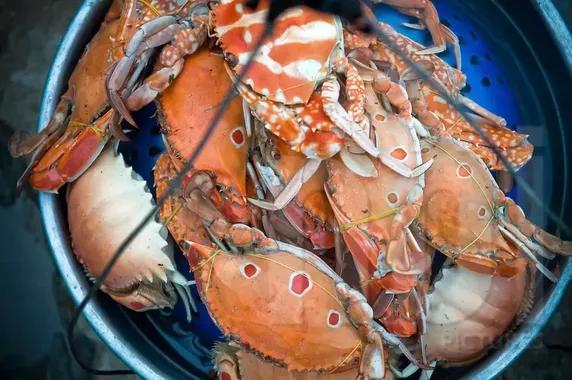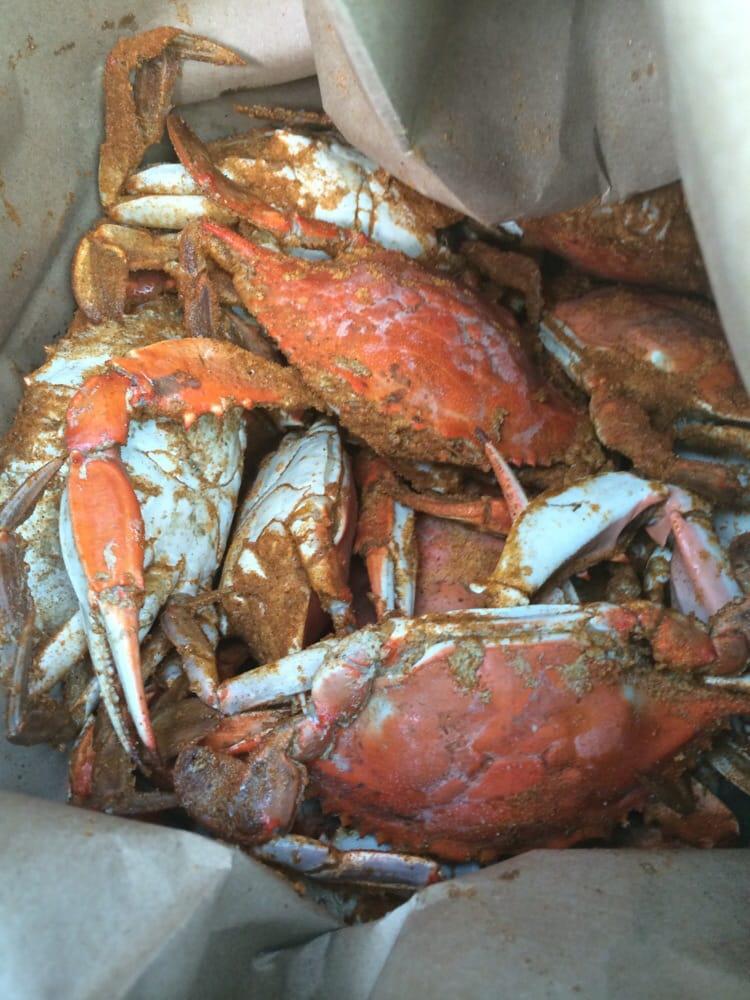The first image is the image on the left, the second image is the image on the right. Given the left and right images, does the statement "At least one of the pictures shows crabs being carried in a round bucket." hold true? Answer yes or no. Yes. The first image is the image on the left, the second image is the image on the right. Analyze the images presented: Is the assertion "The left image shows a pile of forward-facing reddish-orange shell-side up crabs without distinctive spots or a visible container." valid? Answer yes or no. No. 